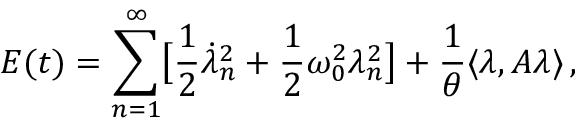Convert formula to latex. <formula><loc_0><loc_0><loc_500><loc_500>E ( t ) = \sum _ { n = 1 } ^ { \infty } \left [ \frac { 1 } { 2 } \dot { \lambda } _ { n } ^ { 2 } + \frac { 1 } { 2 } \omega _ { 0 } ^ { 2 } \lambda _ { n } ^ { 2 } \right ] + \frac { 1 } { \theta } \langle \lambda , A \lambda \rangle \, ,</formula> 